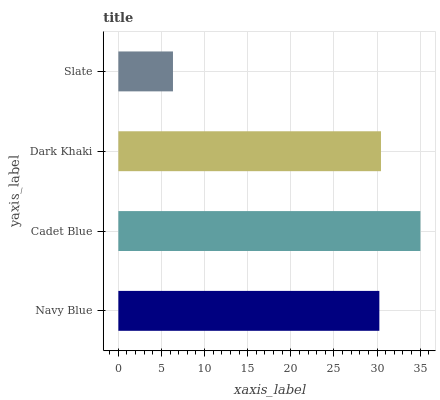Is Slate the minimum?
Answer yes or no. Yes. Is Cadet Blue the maximum?
Answer yes or no. Yes. Is Dark Khaki the minimum?
Answer yes or no. No. Is Dark Khaki the maximum?
Answer yes or no. No. Is Cadet Blue greater than Dark Khaki?
Answer yes or no. Yes. Is Dark Khaki less than Cadet Blue?
Answer yes or no. Yes. Is Dark Khaki greater than Cadet Blue?
Answer yes or no. No. Is Cadet Blue less than Dark Khaki?
Answer yes or no. No. Is Dark Khaki the high median?
Answer yes or no. Yes. Is Navy Blue the low median?
Answer yes or no. Yes. Is Slate the high median?
Answer yes or no. No. Is Slate the low median?
Answer yes or no. No. 